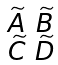<formula> <loc_0><loc_0><loc_500><loc_500>\begin{smallmatrix} \widetilde { A } & \widetilde { B } \\ \widetilde { C } & \widetilde { D } \end{smallmatrix}</formula> 